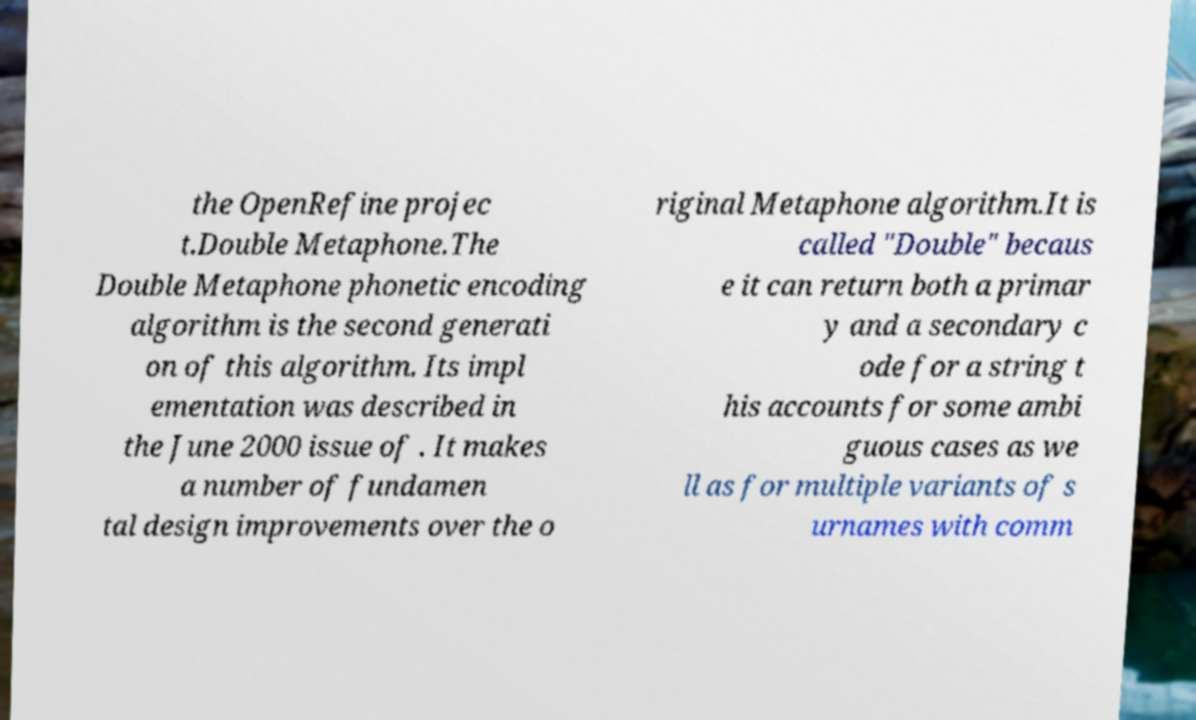Can you read and provide the text displayed in the image?This photo seems to have some interesting text. Can you extract and type it out for me? the OpenRefine projec t.Double Metaphone.The Double Metaphone phonetic encoding algorithm is the second generati on of this algorithm. Its impl ementation was described in the June 2000 issue of . It makes a number of fundamen tal design improvements over the o riginal Metaphone algorithm.It is called "Double" becaus e it can return both a primar y and a secondary c ode for a string t his accounts for some ambi guous cases as we ll as for multiple variants of s urnames with comm 